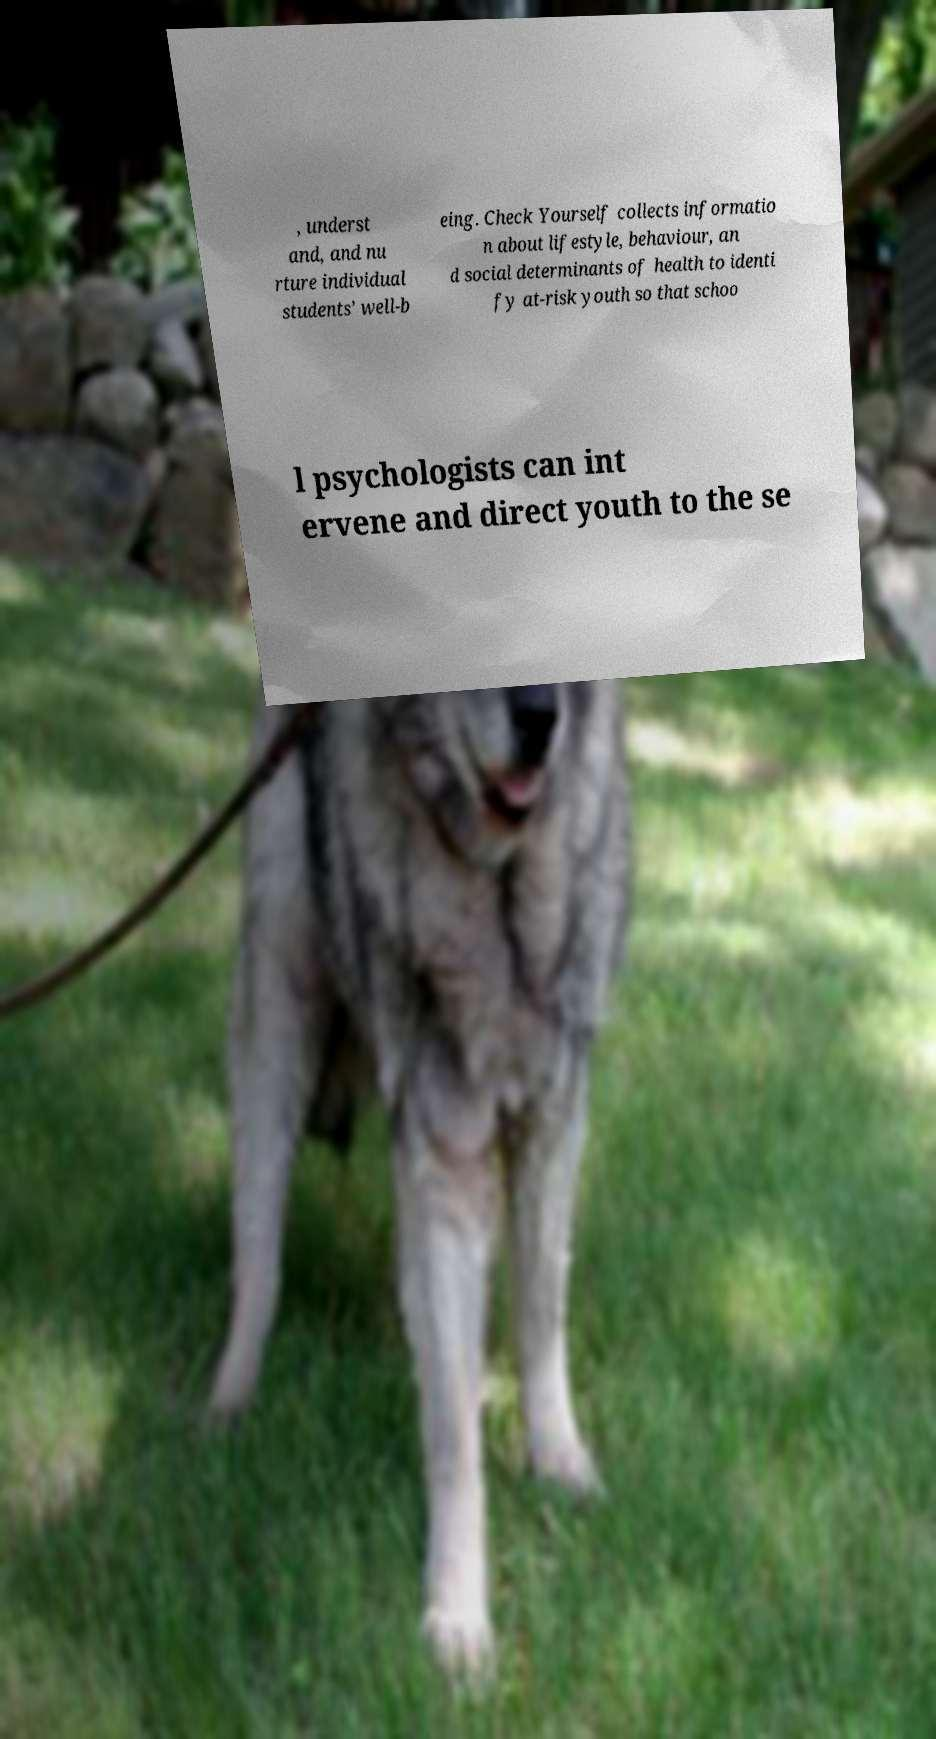I need the written content from this picture converted into text. Can you do that? , underst and, and nu rture individual students’ well-b eing. Check Yourself collects informatio n about lifestyle, behaviour, an d social determinants of health to identi fy at-risk youth so that schoo l psychologists can int ervene and direct youth to the se 